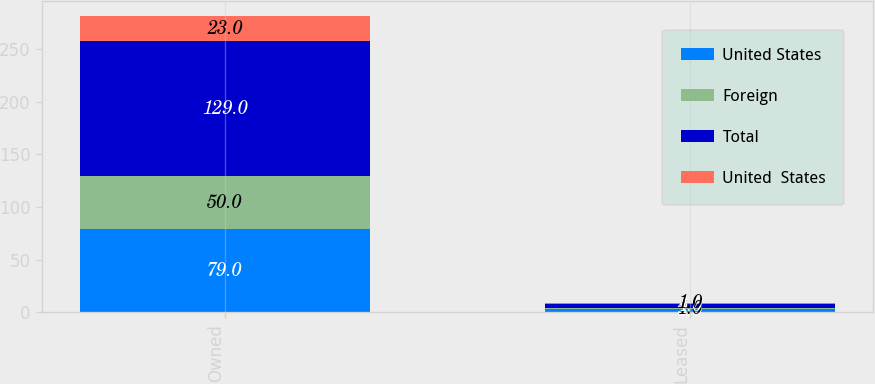Convert chart. <chart><loc_0><loc_0><loc_500><loc_500><stacked_bar_chart><ecel><fcel>Owned<fcel>Leased<nl><fcel>United States<fcel>79<fcel>3<nl><fcel>Foreign<fcel>50<fcel>1<nl><fcel>Total<fcel>129<fcel>4<nl><fcel>United  States<fcel>23<fcel>1<nl></chart> 